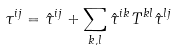Convert formula to latex. <formula><loc_0><loc_0><loc_500><loc_500>\tau ^ { i j } = \hat { \tau } ^ { i j } + \sum _ { k , l } \hat { \tau } ^ { i k } T ^ { k l } \hat { \tau } ^ { l j }</formula> 